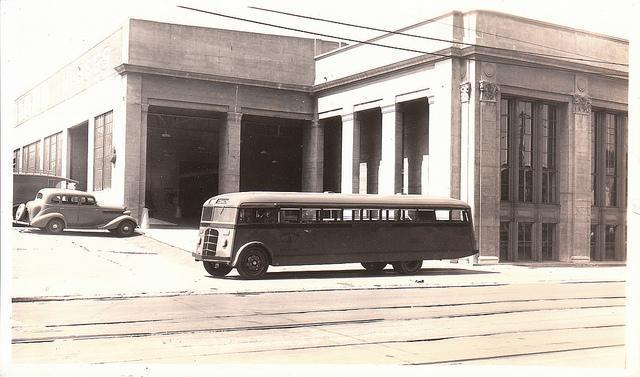How many vehicles are there?
Give a very brief answer. 2. How many park benches have been flooded?
Give a very brief answer. 0. 